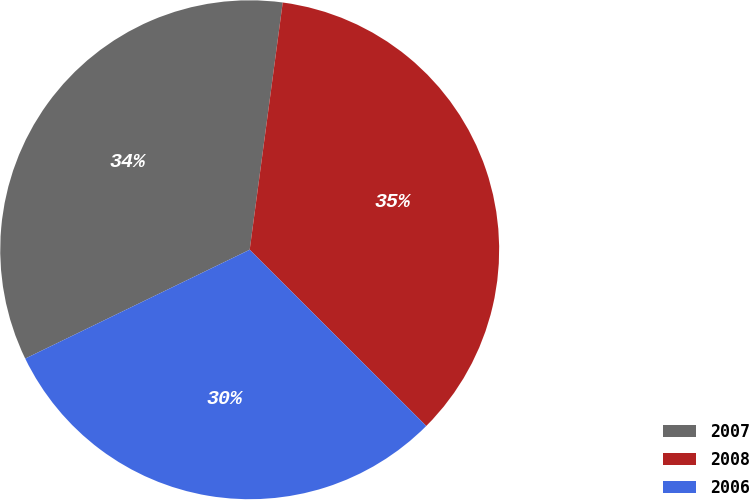Convert chart. <chart><loc_0><loc_0><loc_500><loc_500><pie_chart><fcel>2007<fcel>2008<fcel>2006<nl><fcel>34.3%<fcel>35.37%<fcel>30.33%<nl></chart> 